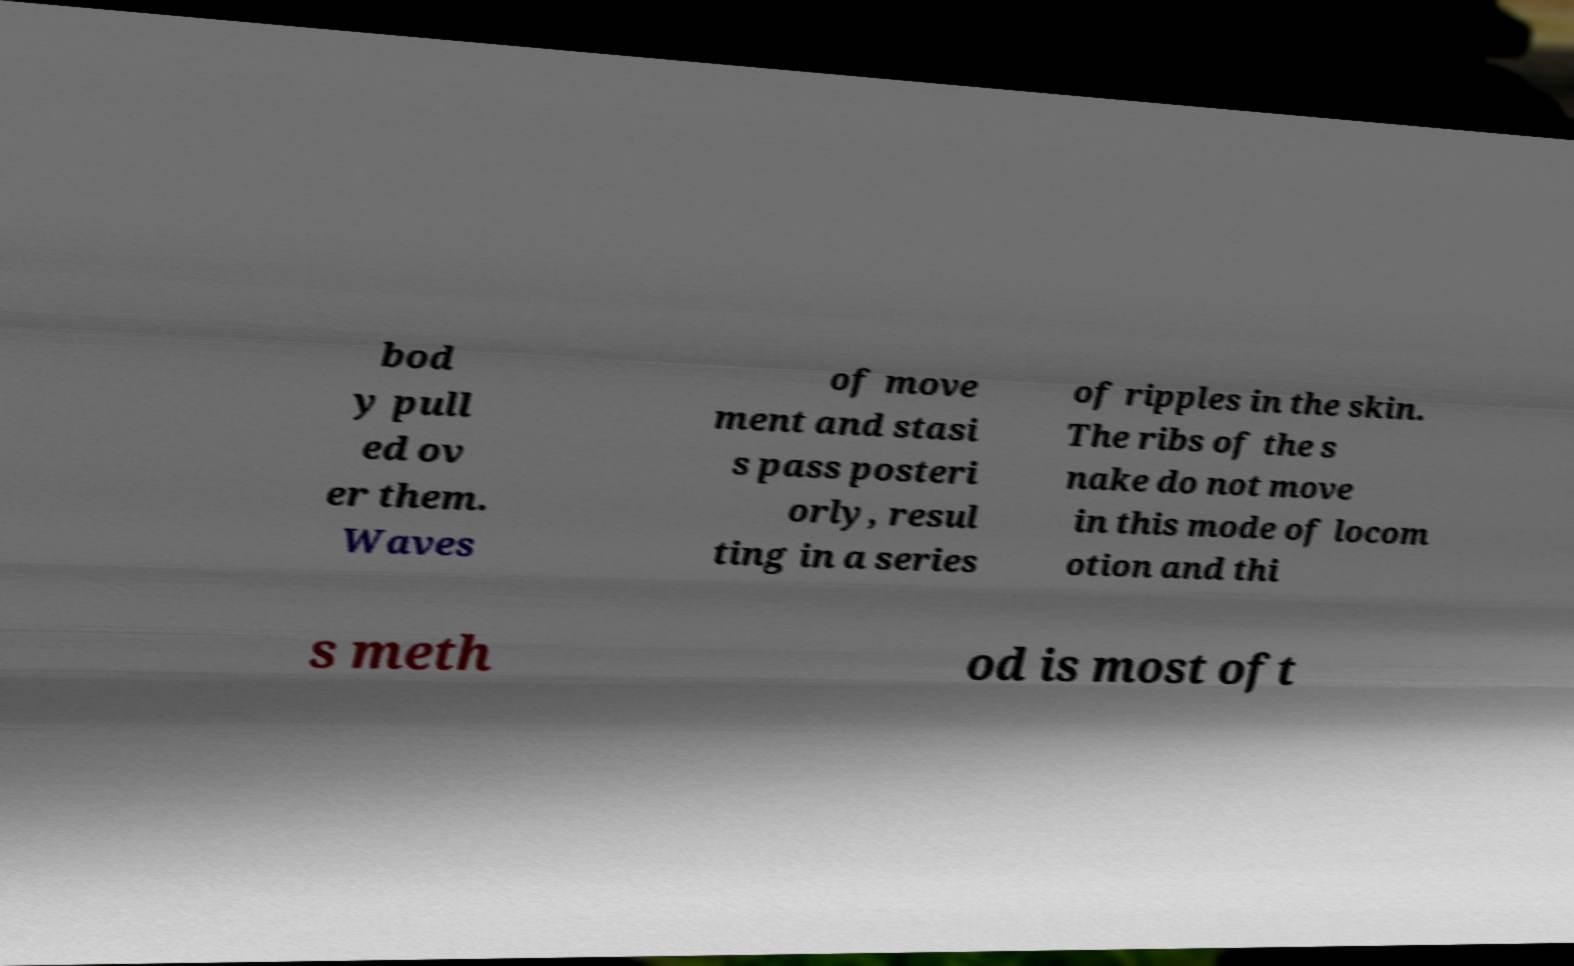Could you assist in decoding the text presented in this image and type it out clearly? bod y pull ed ov er them. Waves of move ment and stasi s pass posteri orly, resul ting in a series of ripples in the skin. The ribs of the s nake do not move in this mode of locom otion and thi s meth od is most oft 